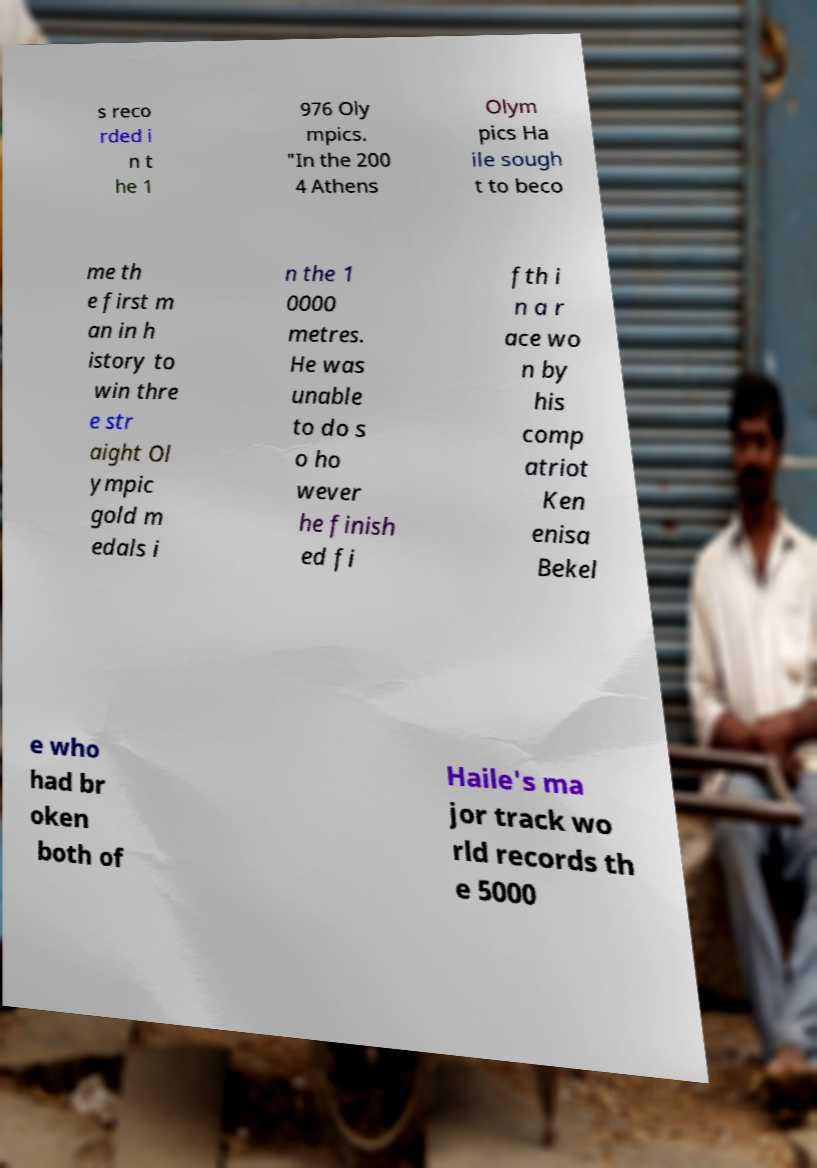Could you extract and type out the text from this image? s reco rded i n t he 1 976 Oly mpics. "In the 200 4 Athens Olym pics Ha ile sough t to beco me th e first m an in h istory to win thre e str aight Ol ympic gold m edals i n the 1 0000 metres. He was unable to do s o ho wever he finish ed fi fth i n a r ace wo n by his comp atriot Ken enisa Bekel e who had br oken both of Haile's ma jor track wo rld records th e 5000 